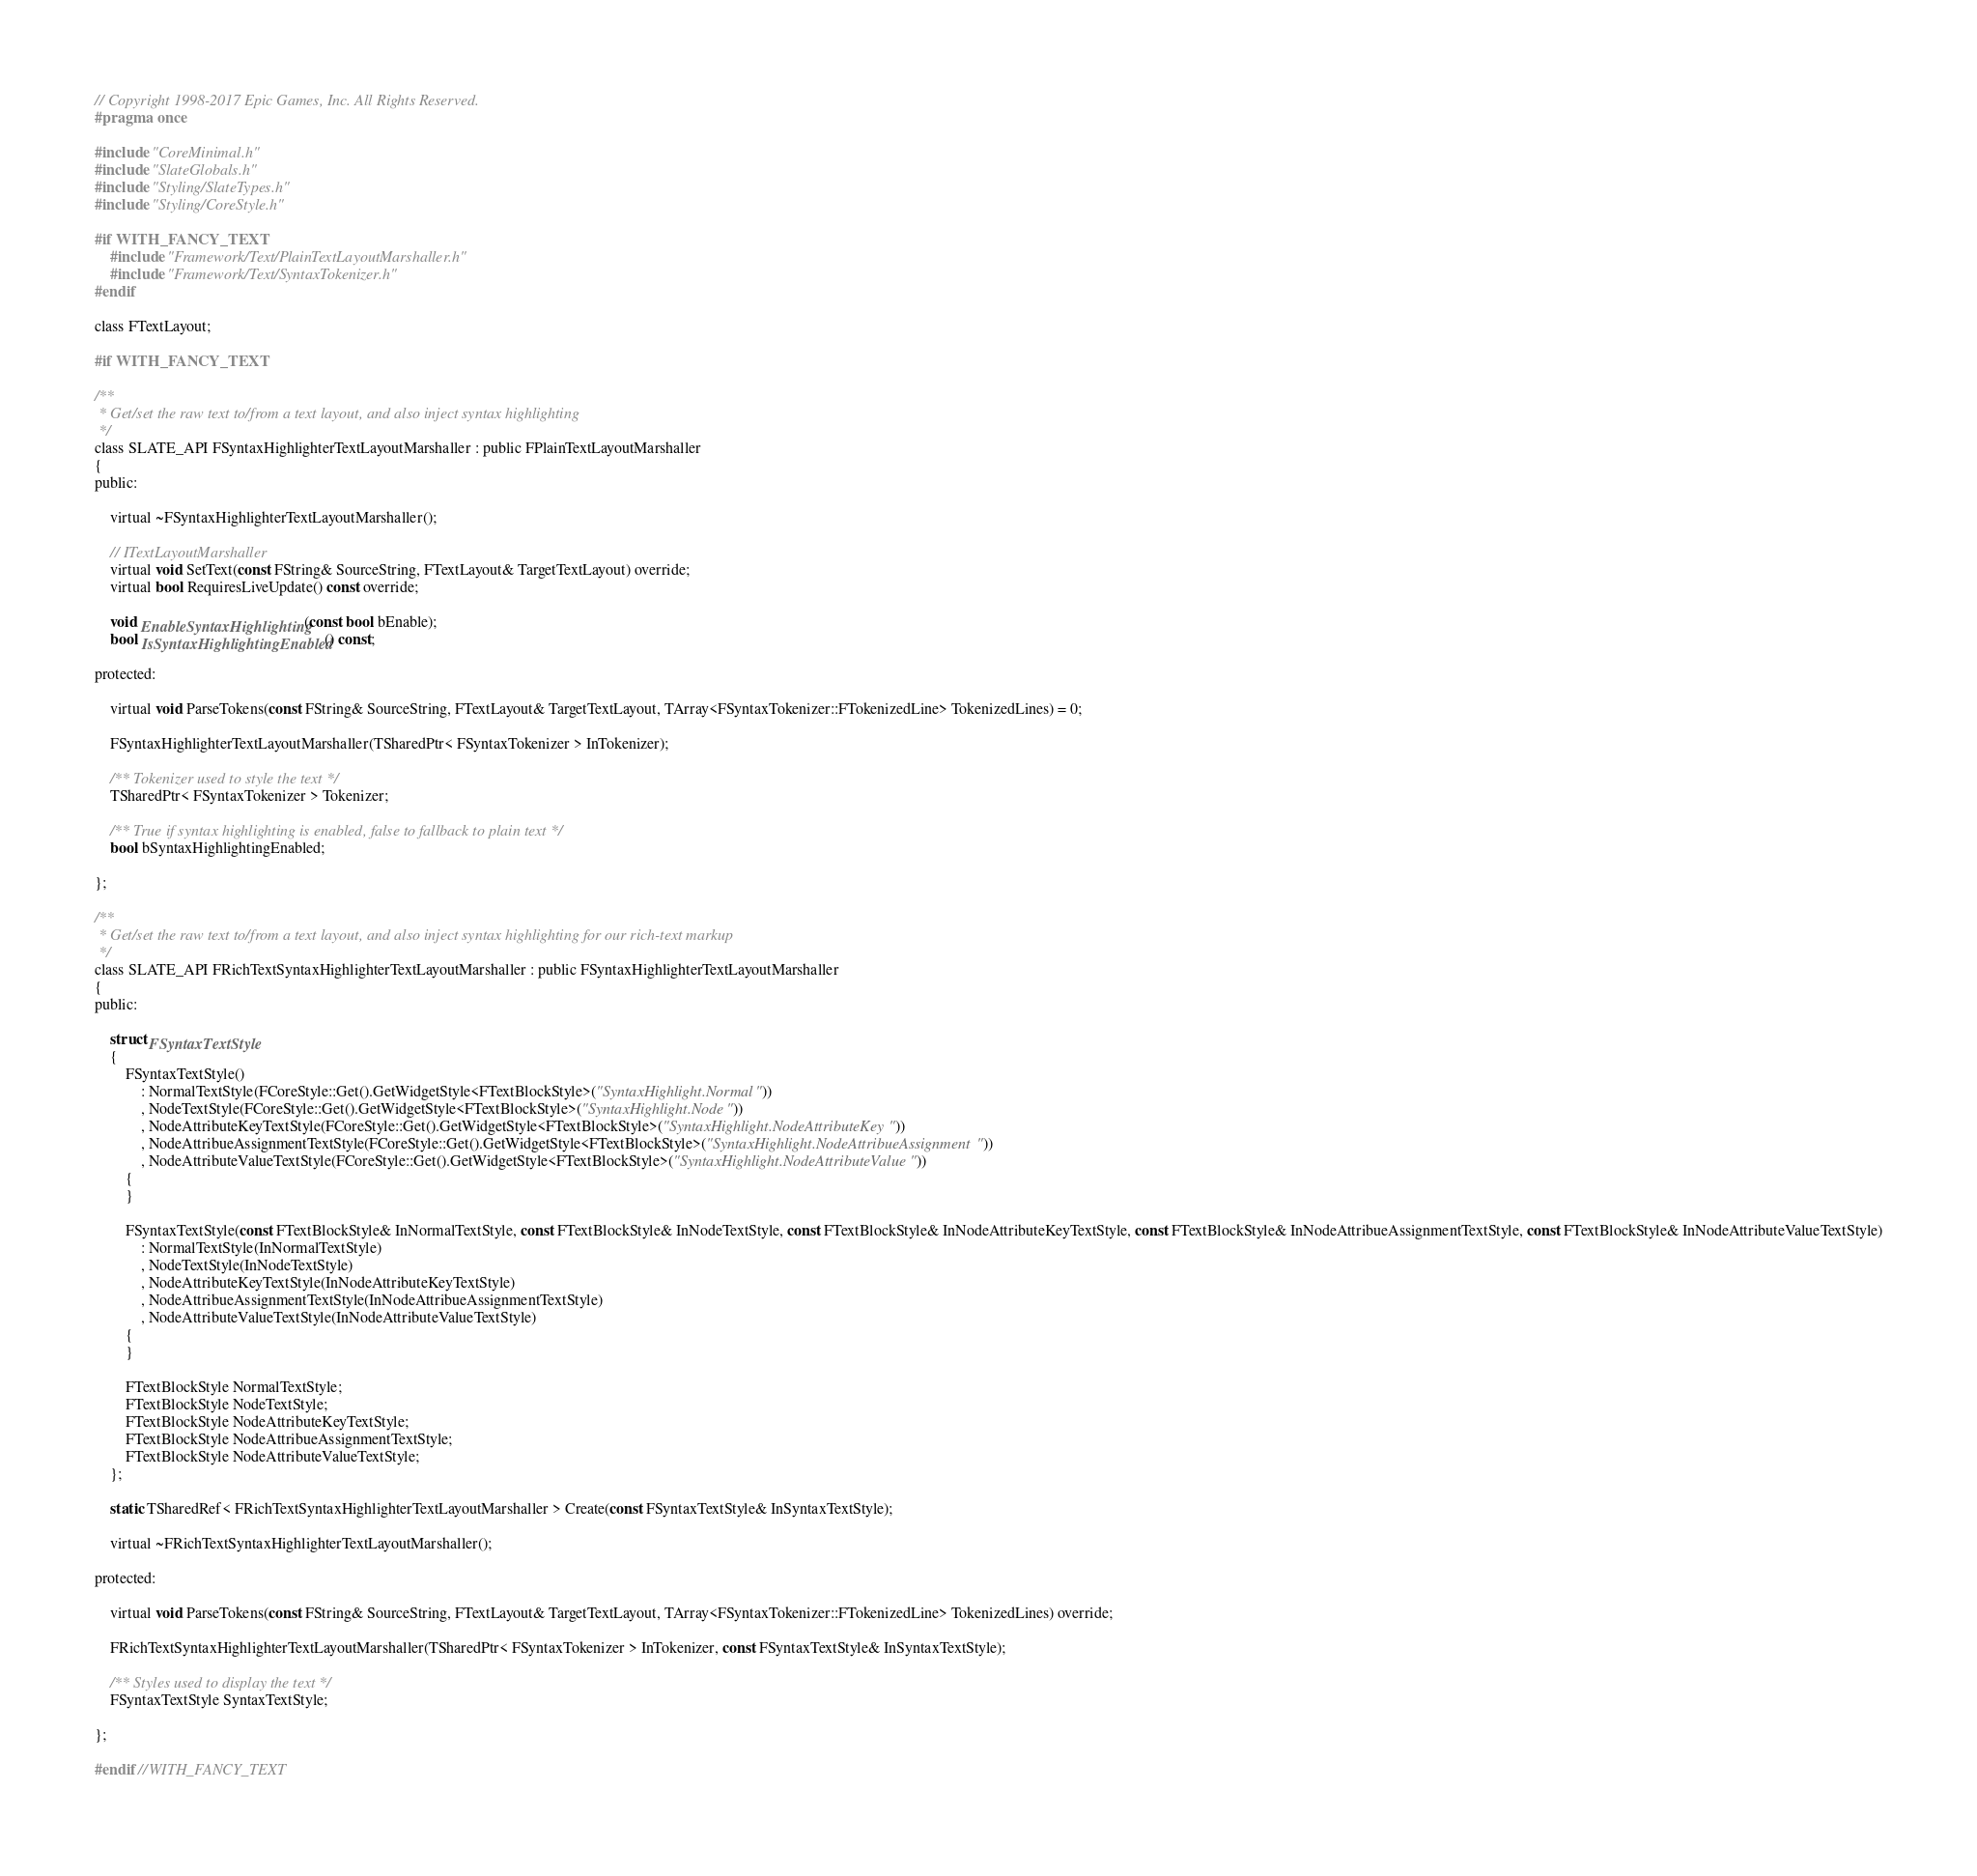<code> <loc_0><loc_0><loc_500><loc_500><_C_>// Copyright 1998-2017 Epic Games, Inc. All Rights Reserved.
#pragma once

#include "CoreMinimal.h"
#include "SlateGlobals.h"
#include "Styling/SlateTypes.h"
#include "Styling/CoreStyle.h"

#if WITH_FANCY_TEXT
	#include "Framework/Text/PlainTextLayoutMarshaller.h"
	#include "Framework/Text/SyntaxTokenizer.h"
#endif

class FTextLayout;

#if WITH_FANCY_TEXT

/**
 * Get/set the raw text to/from a text layout, and also inject syntax highlighting
 */
class SLATE_API FSyntaxHighlighterTextLayoutMarshaller : public FPlainTextLayoutMarshaller
{
public:

	virtual ~FSyntaxHighlighterTextLayoutMarshaller();

	// ITextLayoutMarshaller
	virtual void SetText(const FString& SourceString, FTextLayout& TargetTextLayout) override;
	virtual bool RequiresLiveUpdate() const override;

	void EnableSyntaxHighlighting(const bool bEnable);
	bool IsSyntaxHighlightingEnabled() const;

protected:

	virtual void ParseTokens(const FString& SourceString, FTextLayout& TargetTextLayout, TArray<FSyntaxTokenizer::FTokenizedLine> TokenizedLines) = 0;

	FSyntaxHighlighterTextLayoutMarshaller(TSharedPtr< FSyntaxTokenizer > InTokenizer);

	/** Tokenizer used to style the text */
	TSharedPtr< FSyntaxTokenizer > Tokenizer;

	/** True if syntax highlighting is enabled, false to fallback to plain text */
	bool bSyntaxHighlightingEnabled;

};

/**
 * Get/set the raw text to/from a text layout, and also inject syntax highlighting for our rich-text markup
 */
class SLATE_API FRichTextSyntaxHighlighterTextLayoutMarshaller : public FSyntaxHighlighterTextLayoutMarshaller
{
public:

	struct FSyntaxTextStyle
	{
		FSyntaxTextStyle()
			: NormalTextStyle(FCoreStyle::Get().GetWidgetStyle<FTextBlockStyle>("SyntaxHighlight.Normal"))
			, NodeTextStyle(FCoreStyle::Get().GetWidgetStyle<FTextBlockStyle>("SyntaxHighlight.Node"))
			, NodeAttributeKeyTextStyle(FCoreStyle::Get().GetWidgetStyle<FTextBlockStyle>("SyntaxHighlight.NodeAttributeKey"))
			, NodeAttribueAssignmentTextStyle(FCoreStyle::Get().GetWidgetStyle<FTextBlockStyle>("SyntaxHighlight.NodeAttribueAssignment"))
			, NodeAttributeValueTextStyle(FCoreStyle::Get().GetWidgetStyle<FTextBlockStyle>("SyntaxHighlight.NodeAttributeValue"))
		{
		}

		FSyntaxTextStyle(const FTextBlockStyle& InNormalTextStyle, const FTextBlockStyle& InNodeTextStyle, const FTextBlockStyle& InNodeAttributeKeyTextStyle, const FTextBlockStyle& InNodeAttribueAssignmentTextStyle, const FTextBlockStyle& InNodeAttributeValueTextStyle)
			: NormalTextStyle(InNormalTextStyle)
			, NodeTextStyle(InNodeTextStyle)
			, NodeAttributeKeyTextStyle(InNodeAttributeKeyTextStyle)
			, NodeAttribueAssignmentTextStyle(InNodeAttribueAssignmentTextStyle)
			, NodeAttributeValueTextStyle(InNodeAttributeValueTextStyle)
		{
		}

		FTextBlockStyle NormalTextStyle;
		FTextBlockStyle NodeTextStyle;
		FTextBlockStyle NodeAttributeKeyTextStyle;
		FTextBlockStyle NodeAttribueAssignmentTextStyle;
		FTextBlockStyle NodeAttributeValueTextStyle;
	};

	static TSharedRef< FRichTextSyntaxHighlighterTextLayoutMarshaller > Create(const FSyntaxTextStyle& InSyntaxTextStyle);

	virtual ~FRichTextSyntaxHighlighterTextLayoutMarshaller();

protected:

	virtual void ParseTokens(const FString& SourceString, FTextLayout& TargetTextLayout, TArray<FSyntaxTokenizer::FTokenizedLine> TokenizedLines) override;

	FRichTextSyntaxHighlighterTextLayoutMarshaller(TSharedPtr< FSyntaxTokenizer > InTokenizer, const FSyntaxTextStyle& InSyntaxTextStyle);

	/** Styles used to display the text */
	FSyntaxTextStyle SyntaxTextStyle;

};

#endif //WITH_FANCY_TEXT
</code> 